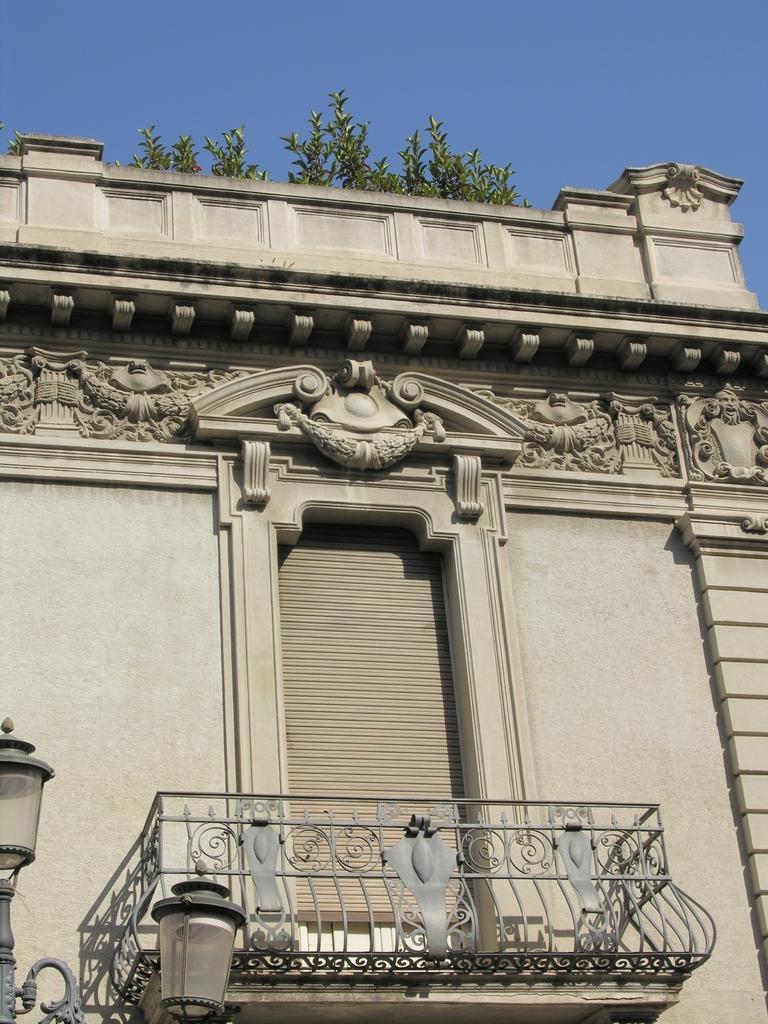Could you give a brief overview of what you see in this image? In this picture we can see a building, there are two lights at the left bottom, we can see balcony at the bottom, there are some plants and the sky at the top of the picture. 